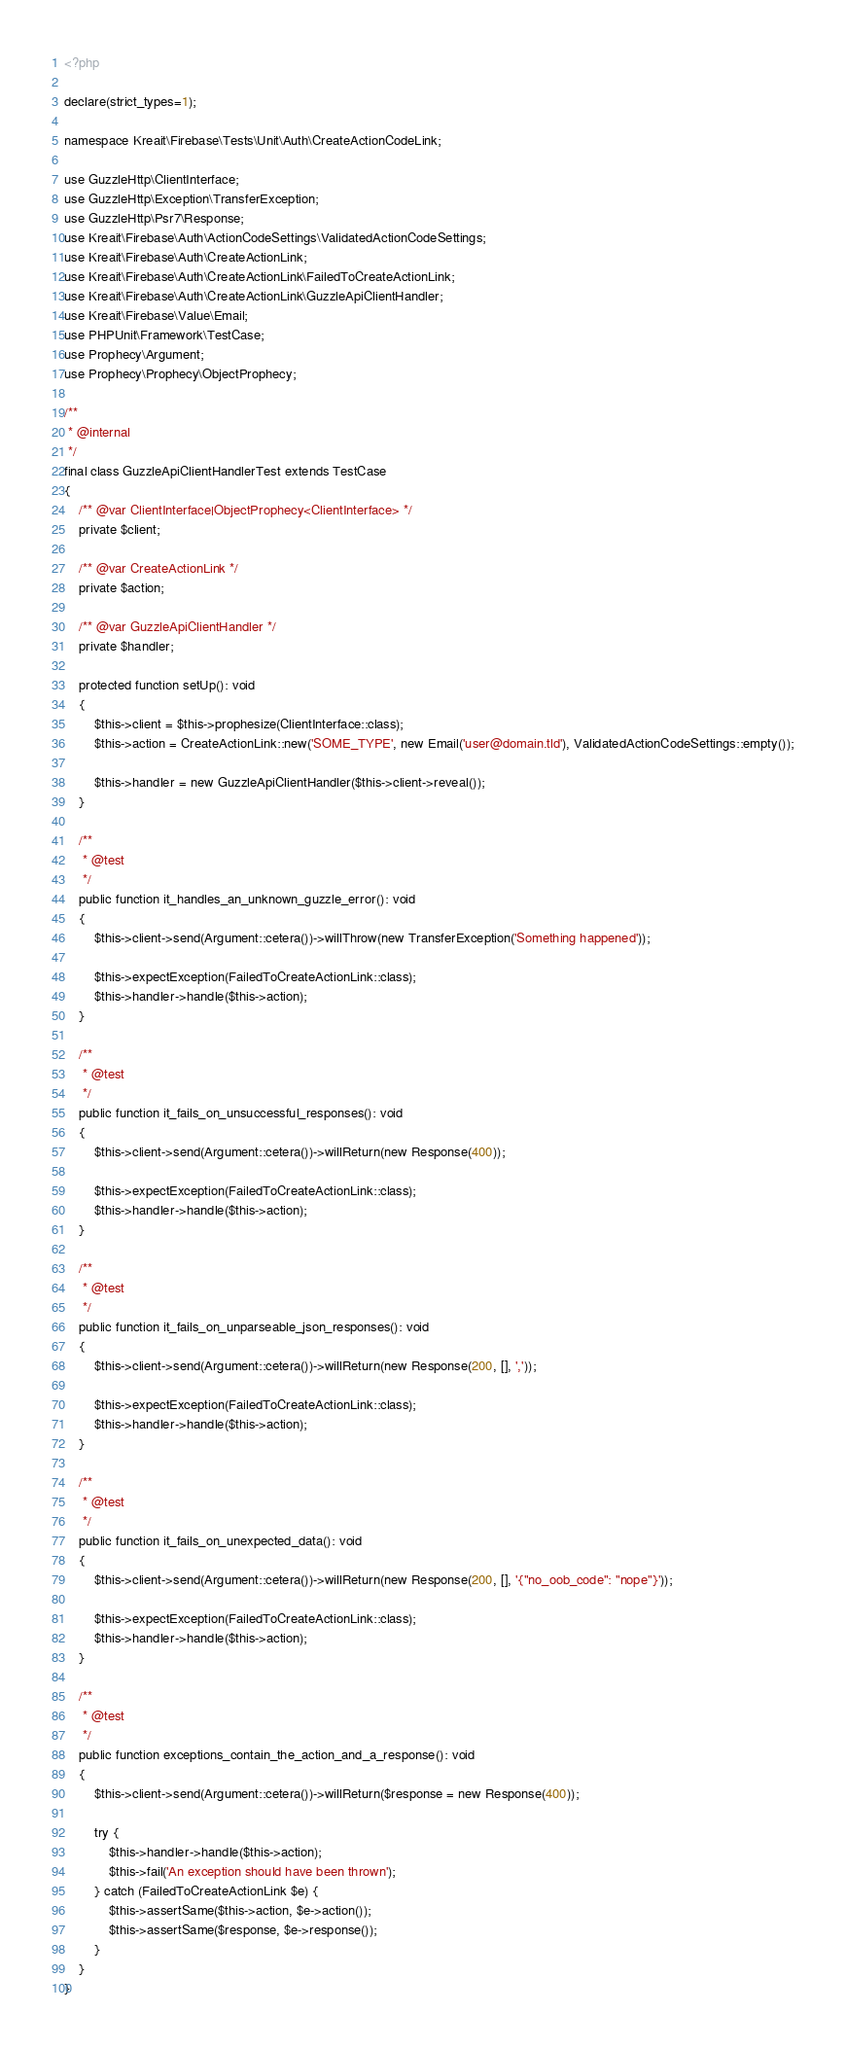Convert code to text. <code><loc_0><loc_0><loc_500><loc_500><_PHP_><?php

declare(strict_types=1);

namespace Kreait\Firebase\Tests\Unit\Auth\CreateActionCodeLink;

use GuzzleHttp\ClientInterface;
use GuzzleHttp\Exception\TransferException;
use GuzzleHttp\Psr7\Response;
use Kreait\Firebase\Auth\ActionCodeSettings\ValidatedActionCodeSettings;
use Kreait\Firebase\Auth\CreateActionLink;
use Kreait\Firebase\Auth\CreateActionLink\FailedToCreateActionLink;
use Kreait\Firebase\Auth\CreateActionLink\GuzzleApiClientHandler;
use Kreait\Firebase\Value\Email;
use PHPUnit\Framework\TestCase;
use Prophecy\Argument;
use Prophecy\Prophecy\ObjectProphecy;

/**
 * @internal
 */
final class GuzzleApiClientHandlerTest extends TestCase
{
    /** @var ClientInterface|ObjectProphecy<ClientInterface> */
    private $client;

    /** @var CreateActionLink */
    private $action;

    /** @var GuzzleApiClientHandler */
    private $handler;

    protected function setUp(): void
    {
        $this->client = $this->prophesize(ClientInterface::class);
        $this->action = CreateActionLink::new('SOME_TYPE', new Email('user@domain.tld'), ValidatedActionCodeSettings::empty());

        $this->handler = new GuzzleApiClientHandler($this->client->reveal());
    }

    /**
     * @test
     */
    public function it_handles_an_unknown_guzzle_error(): void
    {
        $this->client->send(Argument::cetera())->willThrow(new TransferException('Something happened'));

        $this->expectException(FailedToCreateActionLink::class);
        $this->handler->handle($this->action);
    }

    /**
     * @test
     */
    public function it_fails_on_unsuccessful_responses(): void
    {
        $this->client->send(Argument::cetera())->willReturn(new Response(400));

        $this->expectException(FailedToCreateActionLink::class);
        $this->handler->handle($this->action);
    }

    /**
     * @test
     */
    public function it_fails_on_unparseable_json_responses(): void
    {
        $this->client->send(Argument::cetera())->willReturn(new Response(200, [], ','));

        $this->expectException(FailedToCreateActionLink::class);
        $this->handler->handle($this->action);
    }

    /**
     * @test
     */
    public function it_fails_on_unexpected_data(): void
    {
        $this->client->send(Argument::cetera())->willReturn(new Response(200, [], '{"no_oob_code": "nope"}'));

        $this->expectException(FailedToCreateActionLink::class);
        $this->handler->handle($this->action);
    }

    /**
     * @test
     */
    public function exceptions_contain_the_action_and_a_response(): void
    {
        $this->client->send(Argument::cetera())->willReturn($response = new Response(400));

        try {
            $this->handler->handle($this->action);
            $this->fail('An exception should have been thrown');
        } catch (FailedToCreateActionLink $e) {
            $this->assertSame($this->action, $e->action());
            $this->assertSame($response, $e->response());
        }
    }
}
</code> 